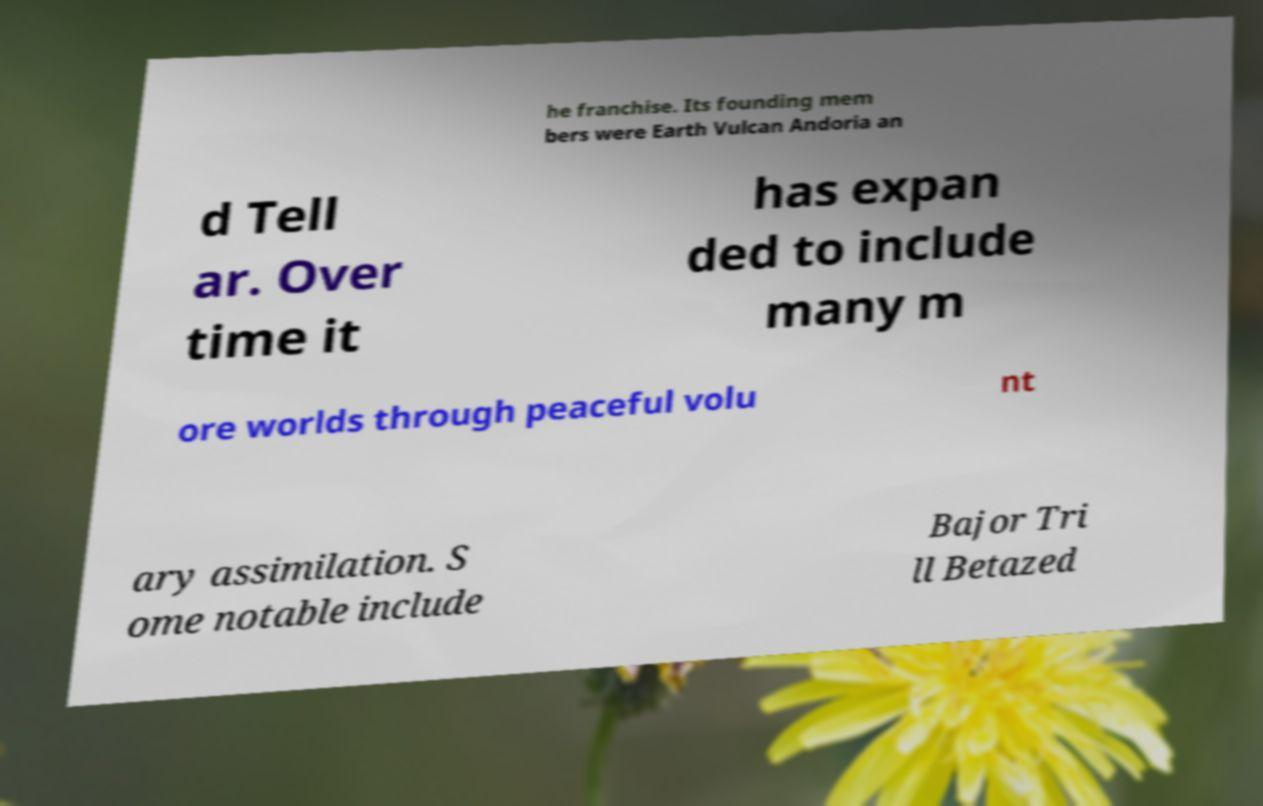Can you accurately transcribe the text from the provided image for me? he franchise. Its founding mem bers were Earth Vulcan Andoria an d Tell ar. Over time it has expan ded to include many m ore worlds through peaceful volu nt ary assimilation. S ome notable include Bajor Tri ll Betazed 